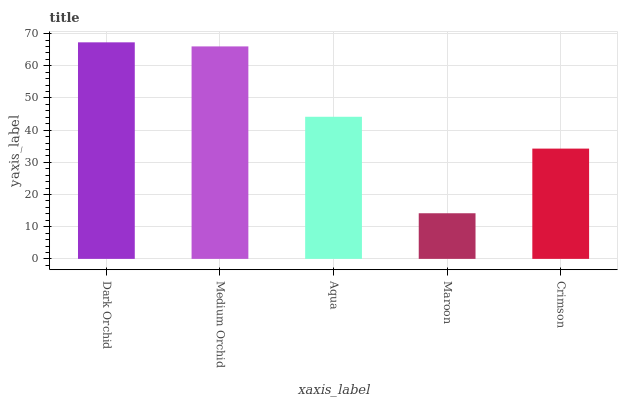Is Maroon the minimum?
Answer yes or no. Yes. Is Dark Orchid the maximum?
Answer yes or no. Yes. Is Medium Orchid the minimum?
Answer yes or no. No. Is Medium Orchid the maximum?
Answer yes or no. No. Is Dark Orchid greater than Medium Orchid?
Answer yes or no. Yes. Is Medium Orchid less than Dark Orchid?
Answer yes or no. Yes. Is Medium Orchid greater than Dark Orchid?
Answer yes or no. No. Is Dark Orchid less than Medium Orchid?
Answer yes or no. No. Is Aqua the high median?
Answer yes or no. Yes. Is Aqua the low median?
Answer yes or no. Yes. Is Crimson the high median?
Answer yes or no. No. Is Dark Orchid the low median?
Answer yes or no. No. 